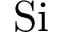Convert formula to latex. <formula><loc_0><loc_0><loc_500><loc_500>S i</formula> 